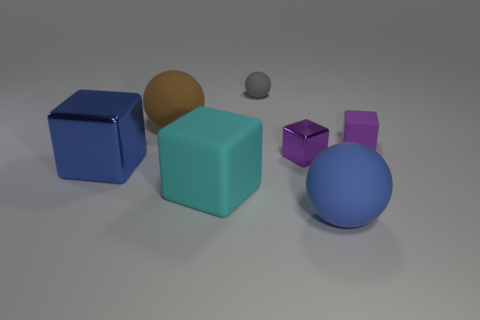How many large objects are both in front of the big brown rubber thing and behind the small purple matte object?
Ensure brevity in your answer.  0. What number of objects are either tiny rubber things behind the big brown ball or matte objects that are behind the tiny metallic block?
Ensure brevity in your answer.  3. What number of other objects are there of the same size as the gray object?
Your answer should be very brief. 2. What shape is the blue object on the right side of the metallic block left of the gray matte thing?
Give a very brief answer. Sphere. There is a sphere on the left side of the gray matte object; is its color the same as the shiny object on the left side of the purple shiny block?
Provide a succinct answer. No. Is there anything else that has the same color as the tiny metal object?
Keep it short and to the point. Yes. The big shiny cube is what color?
Your answer should be compact. Blue. Are there any spheres?
Your answer should be very brief. Yes. Are there any rubber balls on the left side of the blue sphere?
Keep it short and to the point. Yes. There is another small thing that is the same shape as the tiny purple rubber object; what is it made of?
Offer a very short reply. Metal. 